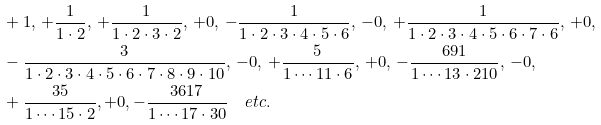Convert formula to latex. <formula><loc_0><loc_0><loc_500><loc_500>& + 1 , \, + \frac { 1 } { 1 \cdot 2 } , \, + \frac { 1 } { 1 \cdot 2 \cdot 3 \cdot 2 } , \, + 0 , \, - \frac { 1 } { 1 \cdot 2 \cdot 3 \cdot 4 \cdot 5 \cdot 6 } , \, - 0 , \, + \frac { 1 } { 1 \cdot 2 \cdot 3 \cdot 4 \cdot 5 \cdot 6 \cdot 7 \cdot 6 } , \, + 0 , \\ & - \frac { 3 } { 1 \cdot 2 \cdot 3 \cdot 4 \cdot 5 \cdot 6 \cdot 7 \cdot 8 \cdot 9 \cdot 1 0 } , \, - 0 , \, + \frac { 5 } { 1 \cdots 1 1 \cdot 6 } , \, + 0 , \, - \frac { 6 9 1 } { 1 \cdots 1 3 \cdot 2 1 0 } , \, - 0 , \\ & + \frac { 3 5 } { 1 \cdots 1 5 \cdot 2 } , + 0 , - \frac { 3 6 1 7 } { 1 \cdots 1 7 \cdot 3 0 } \quad e t c .</formula> 